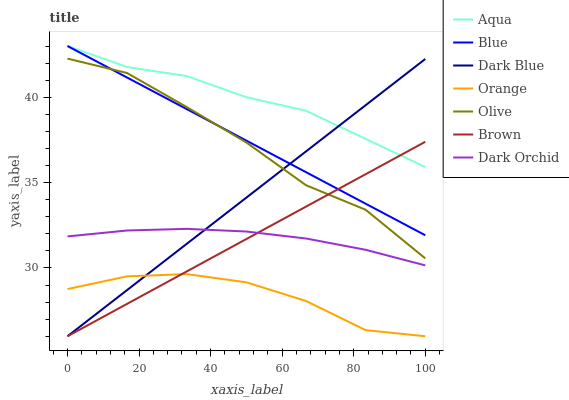Does Orange have the minimum area under the curve?
Answer yes or no. Yes. Does Aqua have the maximum area under the curve?
Answer yes or no. Yes. Does Brown have the minimum area under the curve?
Answer yes or no. No. Does Brown have the maximum area under the curve?
Answer yes or no. No. Is Brown the smoothest?
Answer yes or no. Yes. Is Olive the roughest?
Answer yes or no. Yes. Is Olive the smoothest?
Answer yes or no. No. Is Brown the roughest?
Answer yes or no. No. Does Olive have the lowest value?
Answer yes or no. No. Does Aqua have the highest value?
Answer yes or no. Yes. Does Brown have the highest value?
Answer yes or no. No. Is Dark Orchid less than Blue?
Answer yes or no. Yes. Is Aqua greater than Dark Orchid?
Answer yes or no. Yes. Does Dark Blue intersect Aqua?
Answer yes or no. Yes. Is Dark Blue less than Aqua?
Answer yes or no. No. Is Dark Blue greater than Aqua?
Answer yes or no. No. Does Dark Orchid intersect Blue?
Answer yes or no. No. 